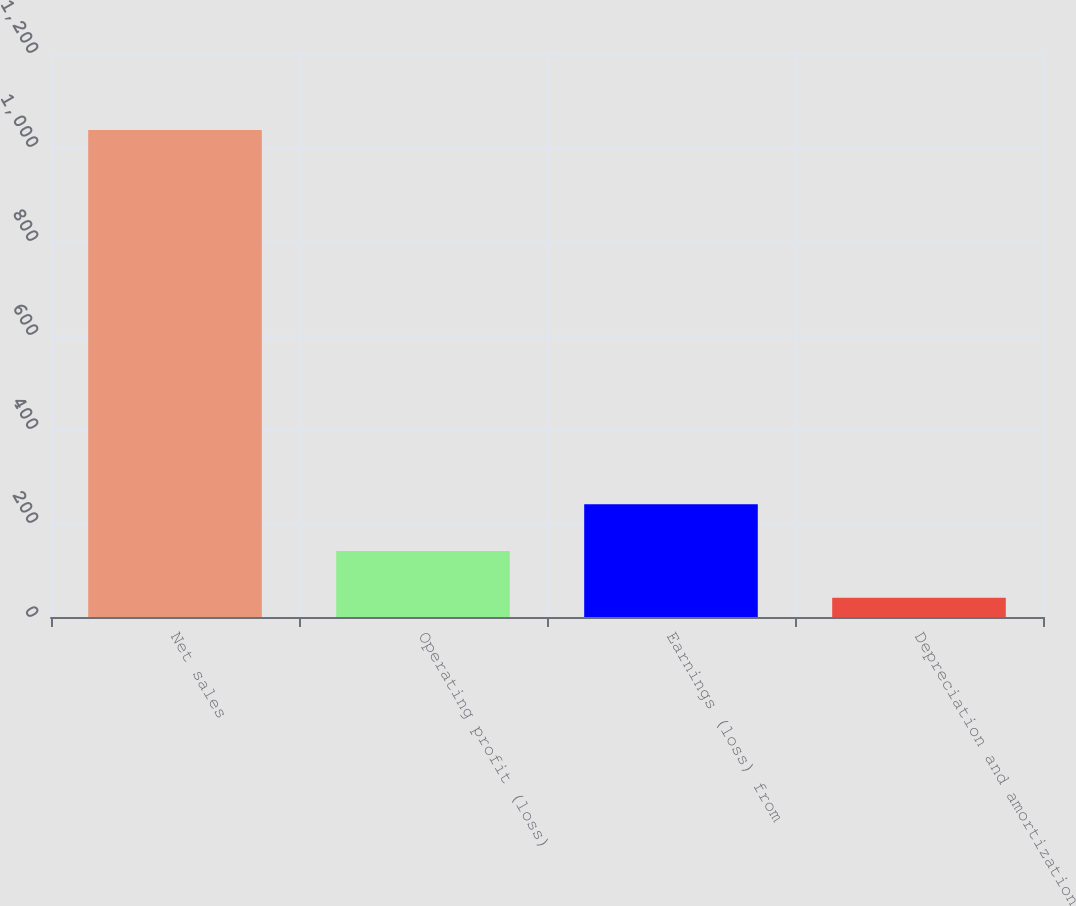Convert chart. <chart><loc_0><loc_0><loc_500><loc_500><bar_chart><fcel>Net sales<fcel>Operating profit (loss)<fcel>Earnings (loss) from<fcel>Depreciation and amortization<nl><fcel>1036<fcel>140.5<fcel>240<fcel>41<nl></chart> 